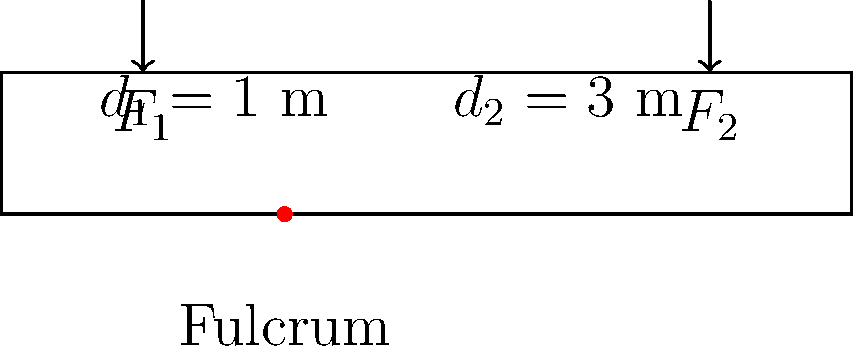In your latest horror novel, you've designed a trap door mechanism using a lever system. The trap door is 4 meters long with a fulcrum placed 1 meter from one end. If a force $F_1 = 600$ N is applied at the short end of the lever, what force $F_2$ is required at the other end to keep the trap door balanced and ready to spring? To solve this problem, we'll use the principle of moments for a lever system:

1. The principle of moments states that for a lever in equilibrium, the sum of clockwise moments equals the sum of anticlockwise moments about the fulcrum.

2. Moment = Force × perpendicular distance from the fulcrum

3. In this case:
   $F_1 \times d_1 = F_2 \times d_2$

4. We know:
   $F_1 = 600$ N
   $d_1 = 1$ m
   $d_2 = 3$ m

5. Substituting these values:
   $600 \times 1 = F_2 \times 3$

6. Simplifying:
   $600 = 3F_2$

7. Solving for $F_2$:
   $F_2 = 600 \div 3 = 200$ N

Therefore, a force of 200 N is required at the long end of the lever to keep the trap door balanced.
Answer: 200 N 